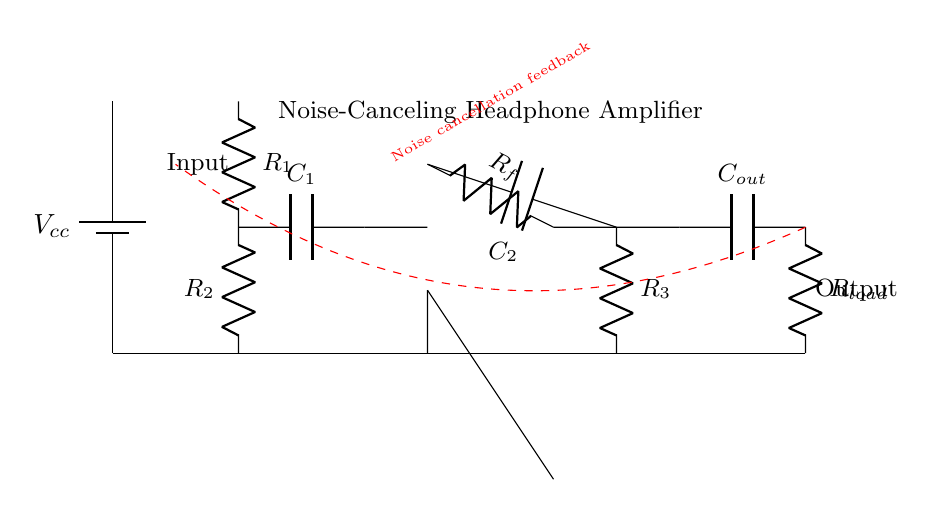What is the power supply component in this circuit? The power supply component is represented by the battery symbol, which indicates the source voltage for the circuit.
Answer: Battery What does R1 do in this circuit? R1 is a resistor in the input stage, likely used to limit current and provide impedance matching for the input signal.
Answer: Limiting current What is the function of the operational amplifier? The operational amplifier amplifies the incoming audio signal, contributing to noise cancellation by processing the input voltage against feedback from the output.
Answer: Amplification How many capacitors are in this circuit? There are three capacitors shown in the circuit diagram that are used for filtering and coupling purposes.
Answer: Three What is the purpose of the feedback loop involving Rf and R3? The feedback loop stabilizes the gain of the operational amplifier, ensuring that the output closely follows the desired input signal with minimized noise.
Answer: Gain stabilization What type of circuit is represented? The circuit is a noise-canceling headphone amplifier, specifically designed to reduce unwanted ambient noise while amplifying audio signals.
Answer: Noise-canceling amplifier What is the load connected to in this circuit? The load is connected to the output stage through the resistor labeled Rload, which represents the headphones or speakers receiving the amplified signal.
Answer: Headphones 